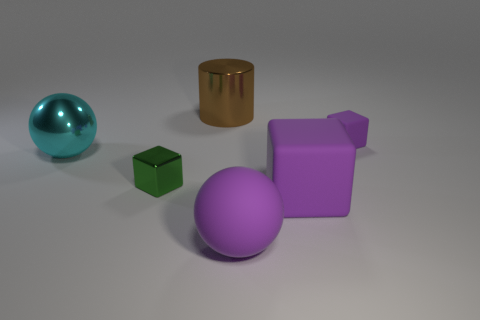Add 3 cyan shiny cylinders. How many objects exist? 9 Subtract all cylinders. How many objects are left? 5 Subtract 0 gray spheres. How many objects are left? 6 Subtract all tiny gray shiny cylinders. Subtract all shiny objects. How many objects are left? 3 Add 3 tiny purple cubes. How many tiny purple cubes are left? 4 Add 4 purple rubber blocks. How many purple rubber blocks exist? 6 